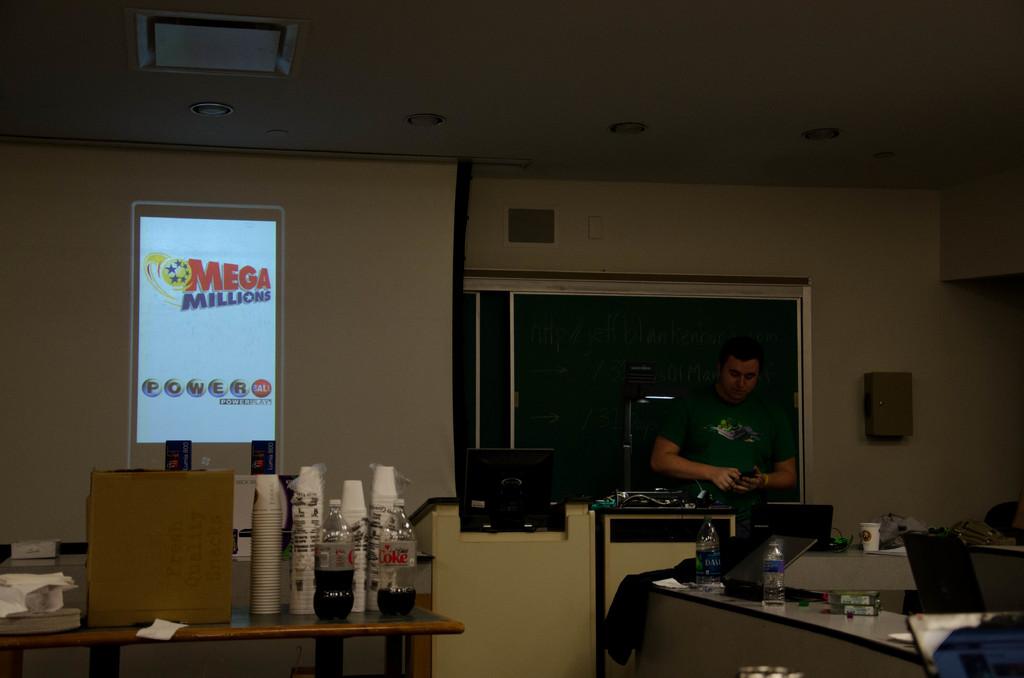What is the name of the soda on the table?
Provide a short and direct response. Coke. What lottery is shown on the screen?
Keep it short and to the point. Mega millions. 